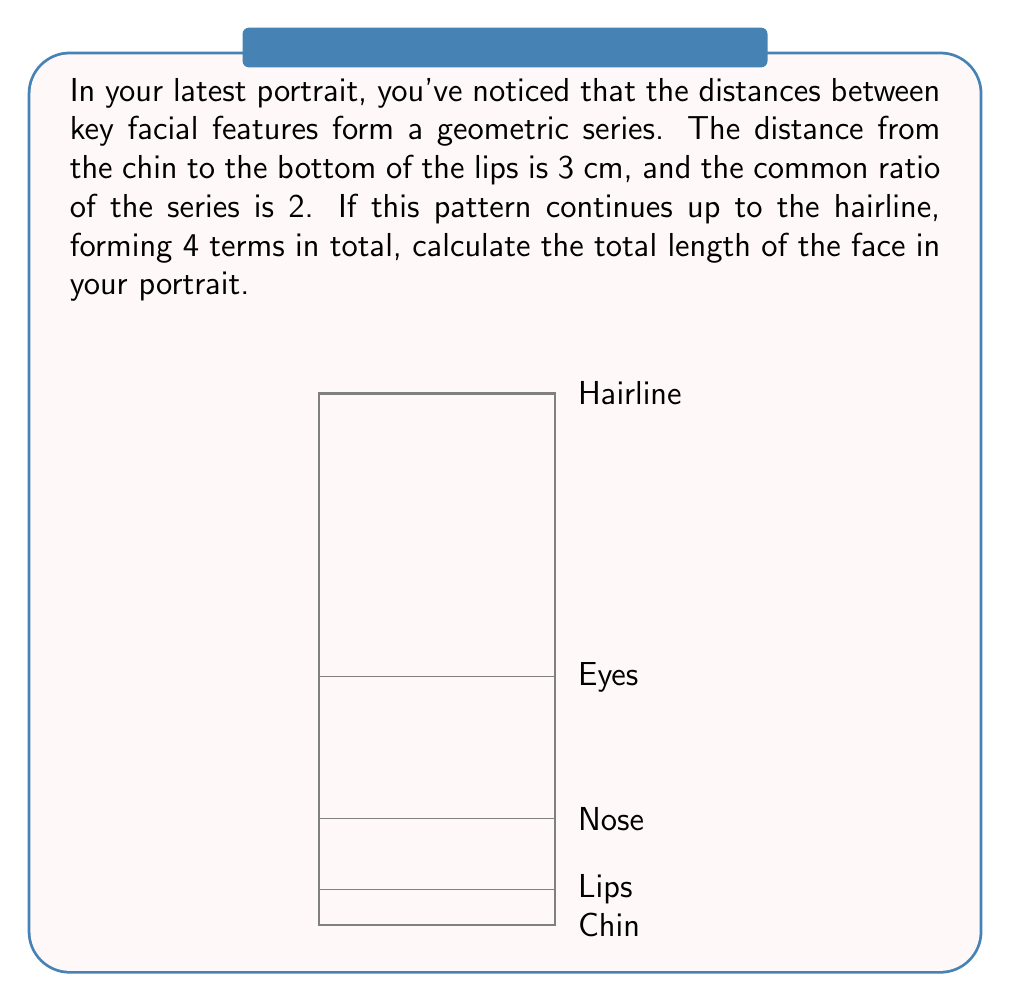Teach me how to tackle this problem. Let's approach this step-by-step:

1) We're dealing with a geometric series where:
   - The first term, $a = 3$ cm
   - The common ratio, $r = 2$
   - The number of terms, $n = 4$

2) The formula for the sum of a geometric series is:

   $$S_n = \frac{a(1-r^n)}{1-r}$$

   Where $S_n$ is the sum of the series, $a$ is the first term, $r$ is the common ratio, and $n$ is the number of terms.

3) Substituting our values:

   $$S_4 = \frac{3(1-2^4)}{1-2}$$

4) Simplify:
   $$S_4 = \frac{3(1-16)}{-1} = \frac{3(-15)}{-1} = 45$$

5) Therefore, the total length of the face in the portrait is 45 cm.

This geometric progression in facial features creates a sense of harmony and proportion in the portrait, reflecting the golden ratio often found in classical art and nature.
Answer: 45 cm 